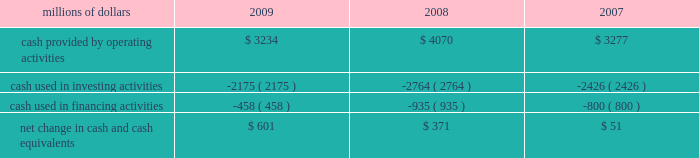Have access to liquidity by issuing bonds to public or private investors based on our assessment of the current condition of the credit markets .
At december 31 , 2009 , we had a working capital surplus of approximately $ 1.0 billion , which reflects our decision to maintain additional cash reserves to enhance liquidity in response to difficult economic conditions .
At december 31 , 2008 , we had a working capital deficit of approximately $ 100 million .
Historically , we have had a working capital deficit , which is common in our industry and does not indicate a lack of liquidity .
We maintain adequate resources and , when necessary , have access to capital to meet any daily and short-term cash requirements , and we have sufficient financial capacity to satisfy our current liabilities .
Cash flows millions of dollars 2009 2008 2007 .
Operating activities lower net income in 2009 , a reduction of $ 184 million in the outstanding balance of our accounts receivable securitization program , higher pension contributions of $ 72 million , and changes to working capital combined to decrease cash provided by operating activities compared to 2008 .
Higher net income and changes in working capital combined to increase cash provided by operating activities in 2008 compared to 2007 .
In addition , accelerated tax deductions enacted in 2008 on certain new operating assets resulted in lower income tax payments in 2008 versus 2007 .
Voluntary pension contributions in 2008 totaling $ 200 million and other pension contributions of $ 8 million partially offset the year-over-year increase versus 2007 .
Investing activities lower capital investments and higher proceeds from asset sales drove the decrease in cash used in investing activities in 2009 versus 2008 .
Increased capital investments and lower proceeds from asset sales drove the increase in cash used in investing activities in 2008 compared to 2007. .
What was the percentage change in cash provided by operating activities from 2008 to 2009? 
Computations: ((3234 - 4070) / 4070)
Answer: -0.20541. 